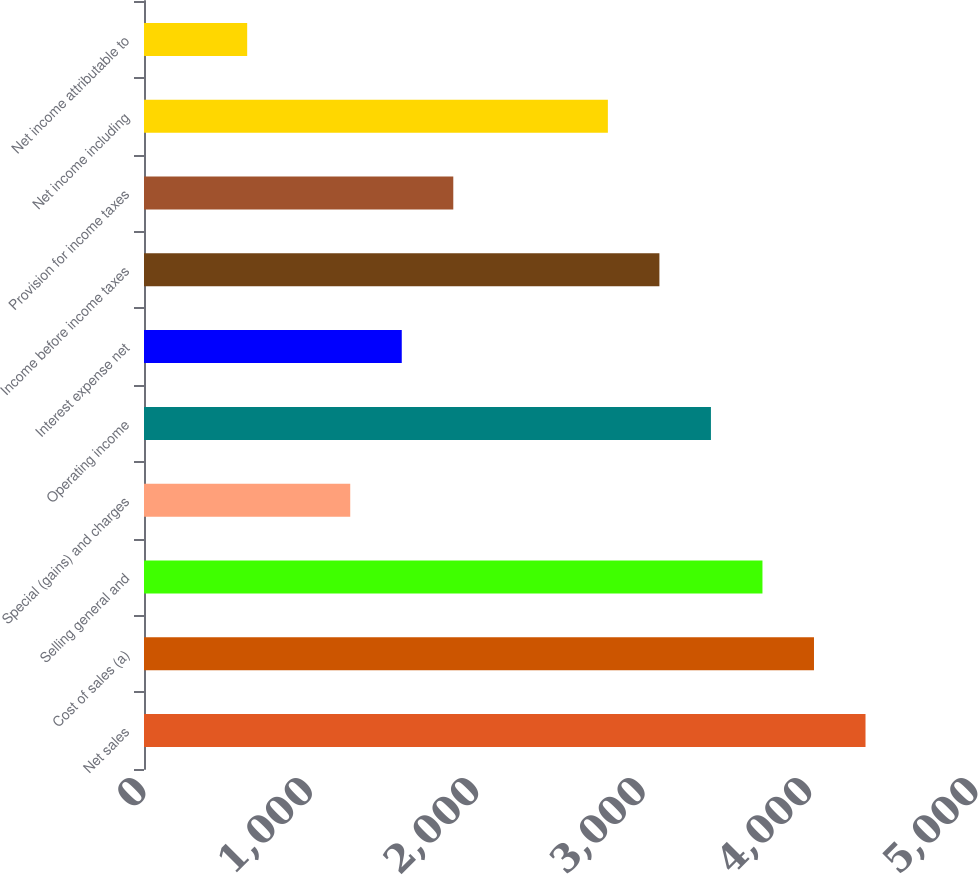<chart> <loc_0><loc_0><loc_500><loc_500><bar_chart><fcel>Net sales<fcel>Cost of sales (a)<fcel>Selling general and<fcel>Special (gains) and charges<fcel>Operating income<fcel>Interest expense net<fcel>Income before income taxes<fcel>Provision for income taxes<fcel>Net income including<fcel>Net income attributable to<nl><fcel>4336.01<fcel>4026.35<fcel>3716.69<fcel>1239.41<fcel>3407.03<fcel>1549.07<fcel>3097.37<fcel>1858.73<fcel>2787.71<fcel>620.09<nl></chart> 